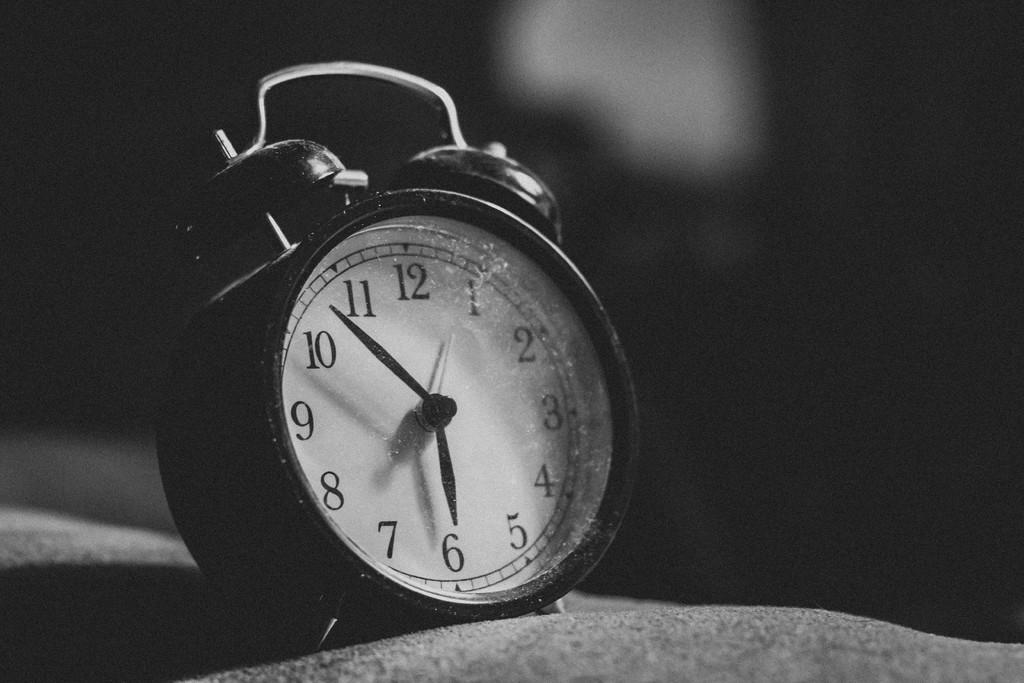Provide a one-sentence caption for the provided image. A black and white picture of an old alarm clock that reads "6:50". 